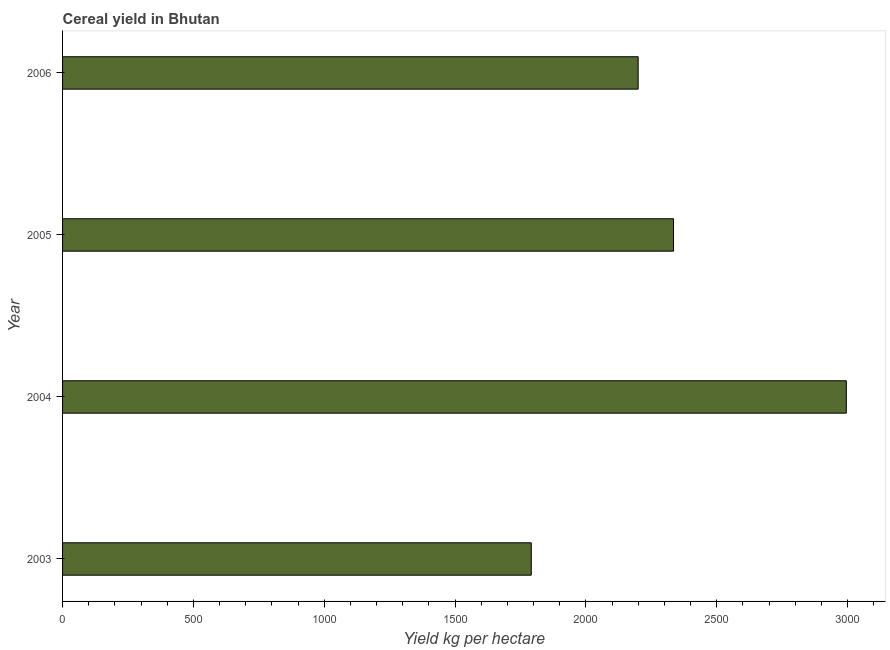Does the graph contain any zero values?
Your answer should be very brief. No. What is the title of the graph?
Your answer should be compact. Cereal yield in Bhutan. What is the label or title of the X-axis?
Ensure brevity in your answer.  Yield kg per hectare. What is the label or title of the Y-axis?
Ensure brevity in your answer.  Year. What is the cereal yield in 2004?
Make the answer very short. 2995.21. Across all years, what is the maximum cereal yield?
Your answer should be very brief. 2995.21. Across all years, what is the minimum cereal yield?
Provide a succinct answer. 1791.25. What is the sum of the cereal yield?
Offer a very short reply. 9321.16. What is the difference between the cereal yield in 2003 and 2006?
Give a very brief answer. -408.49. What is the average cereal yield per year?
Make the answer very short. 2330.29. What is the median cereal yield?
Your response must be concise. 2267.35. In how many years, is the cereal yield greater than 300 kg per hectare?
Offer a terse response. 4. What is the ratio of the cereal yield in 2004 to that in 2006?
Give a very brief answer. 1.36. Is the difference between the cereal yield in 2003 and 2004 greater than the difference between any two years?
Offer a terse response. Yes. What is the difference between the highest and the second highest cereal yield?
Your response must be concise. 660.26. Is the sum of the cereal yield in 2003 and 2006 greater than the maximum cereal yield across all years?
Provide a short and direct response. Yes. What is the difference between the highest and the lowest cereal yield?
Provide a short and direct response. 1203.96. In how many years, is the cereal yield greater than the average cereal yield taken over all years?
Give a very brief answer. 2. What is the Yield kg per hectare of 2003?
Provide a succinct answer. 1791.25. What is the Yield kg per hectare in 2004?
Provide a short and direct response. 2995.21. What is the Yield kg per hectare in 2005?
Your response must be concise. 2334.95. What is the Yield kg per hectare of 2006?
Give a very brief answer. 2199.74. What is the difference between the Yield kg per hectare in 2003 and 2004?
Your response must be concise. -1203.96. What is the difference between the Yield kg per hectare in 2003 and 2005?
Keep it short and to the point. -543.7. What is the difference between the Yield kg per hectare in 2003 and 2006?
Provide a short and direct response. -408.49. What is the difference between the Yield kg per hectare in 2004 and 2005?
Make the answer very short. 660.26. What is the difference between the Yield kg per hectare in 2004 and 2006?
Keep it short and to the point. 795.47. What is the difference between the Yield kg per hectare in 2005 and 2006?
Your answer should be compact. 135.21. What is the ratio of the Yield kg per hectare in 2003 to that in 2004?
Provide a succinct answer. 0.6. What is the ratio of the Yield kg per hectare in 2003 to that in 2005?
Offer a terse response. 0.77. What is the ratio of the Yield kg per hectare in 2003 to that in 2006?
Give a very brief answer. 0.81. What is the ratio of the Yield kg per hectare in 2004 to that in 2005?
Offer a very short reply. 1.28. What is the ratio of the Yield kg per hectare in 2004 to that in 2006?
Give a very brief answer. 1.36. What is the ratio of the Yield kg per hectare in 2005 to that in 2006?
Your response must be concise. 1.06. 